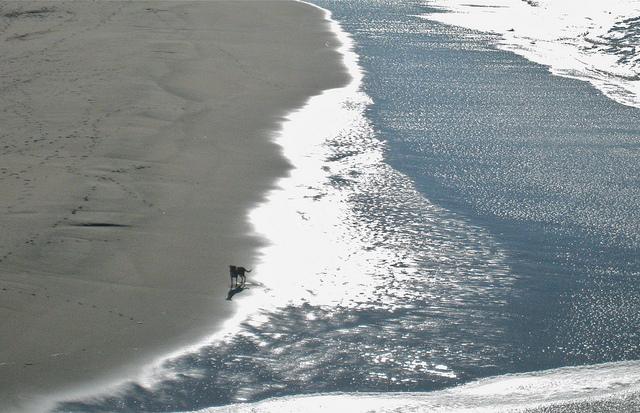Is this a dog?
Keep it brief. Yes. What is the man in the middle of?
Short answer required. Beach. Is the dog a poodle?
Quick response, please. No. Is this an inland location?
Short answer required. No. 